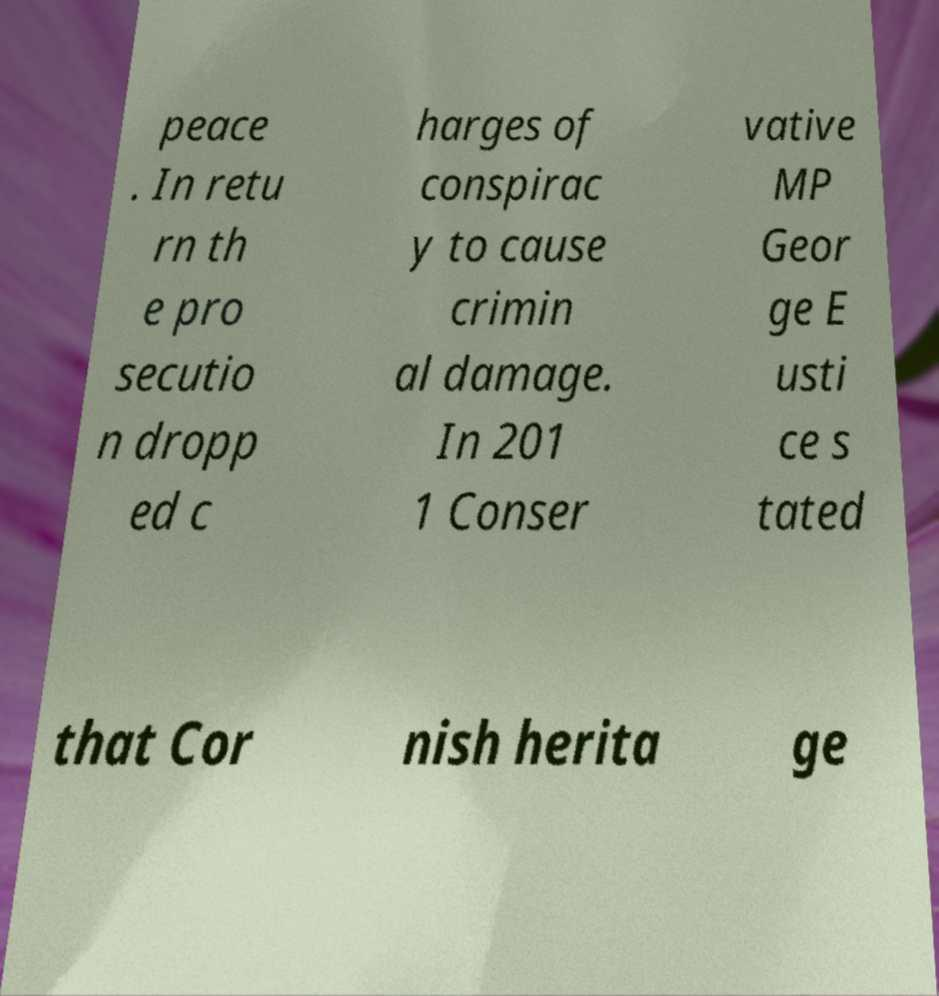Please read and relay the text visible in this image. What does it say? peace . In retu rn th e pro secutio n dropp ed c harges of conspirac y to cause crimin al damage. In 201 1 Conser vative MP Geor ge E usti ce s tated that Cor nish herita ge 